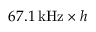Convert formula to latex. <formula><loc_0><loc_0><loc_500><loc_500>6 7 . 1 \, k H z \times h</formula> 